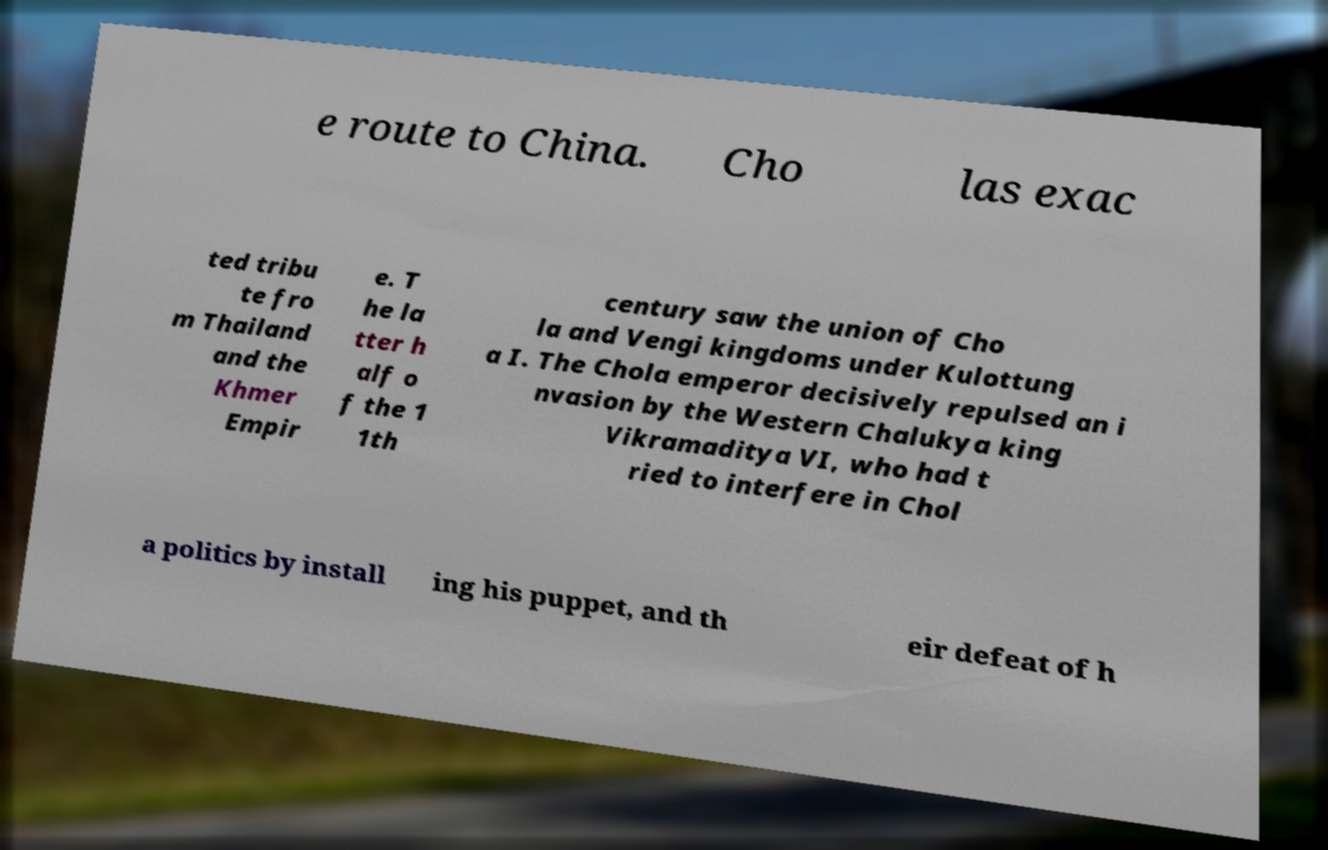What messages or text are displayed in this image? I need them in a readable, typed format. e route to China. Cho las exac ted tribu te fro m Thailand and the Khmer Empir e. T he la tter h alf o f the 1 1th century saw the union of Cho la and Vengi kingdoms under Kulottung a I. The Chola emperor decisively repulsed an i nvasion by the Western Chalukya king Vikramaditya VI, who had t ried to interfere in Chol a politics by install ing his puppet, and th eir defeat of h 